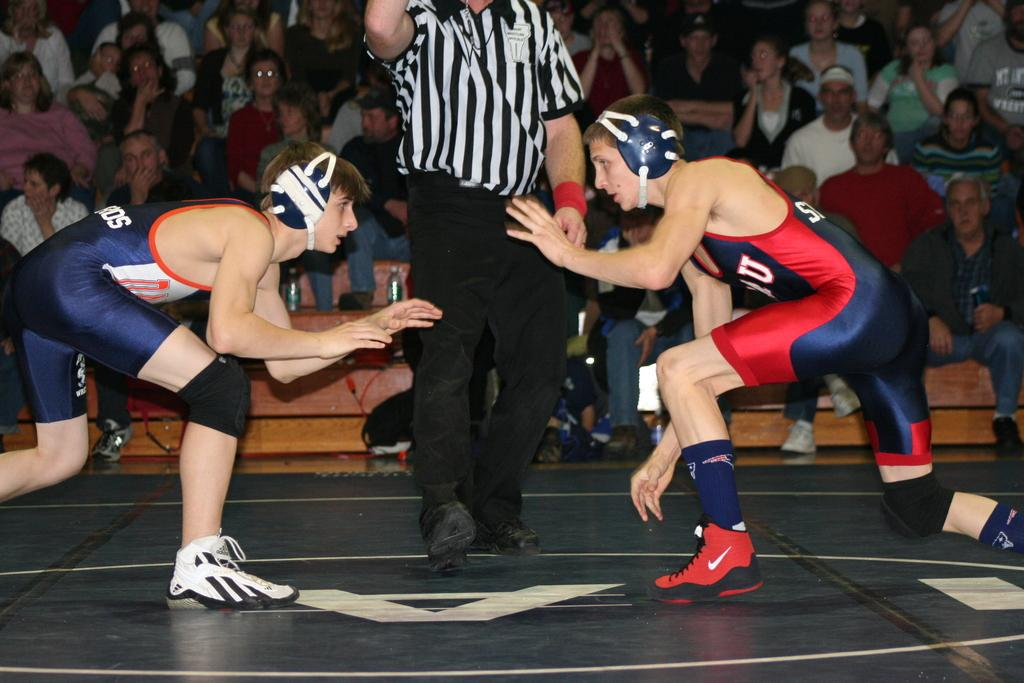<image>
Summarize the visual content of the image. A wrestler in Adidas shoes stands facing a wrestler in shoes with a Nike swoosh on them. 